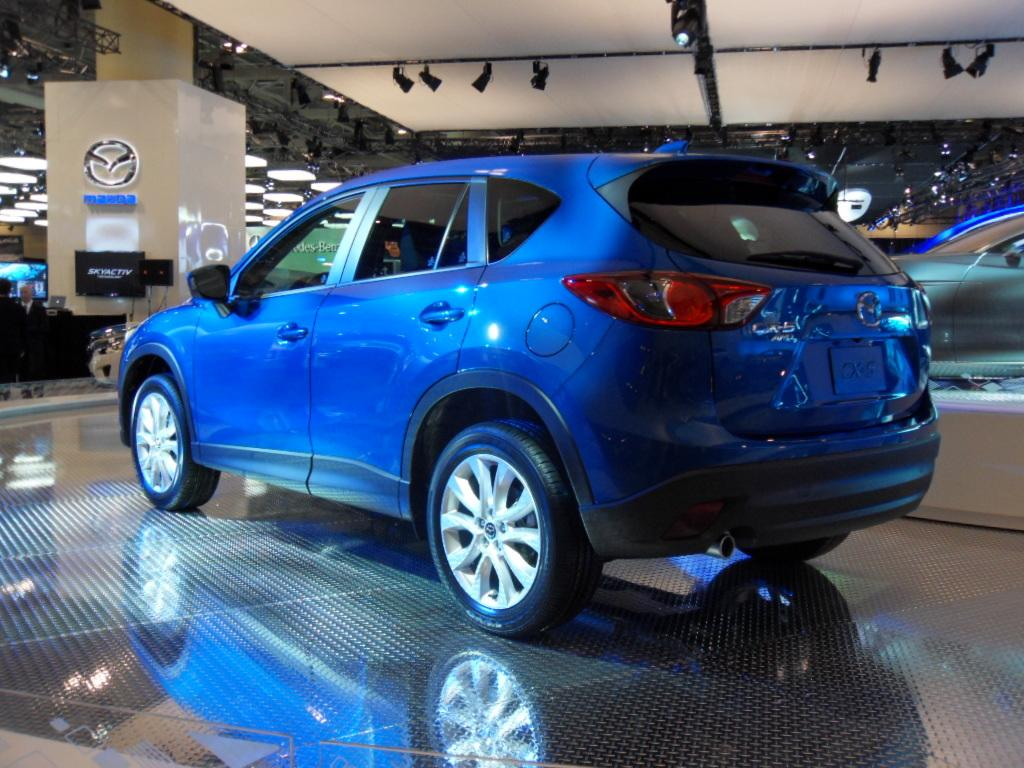What color is the vehicle in the image? The vehicle in the image is blue. What type of surface is visible in the image? The image shows a floor. What are the people in the image wearing? The people in the image are wearing clothes. Can you describe any symbols or designs in the image? There is a logo in the image. How many trees can be seen in the image? There are no trees visible in the image. What color is the orange in the image? There is no orange present in the image. 